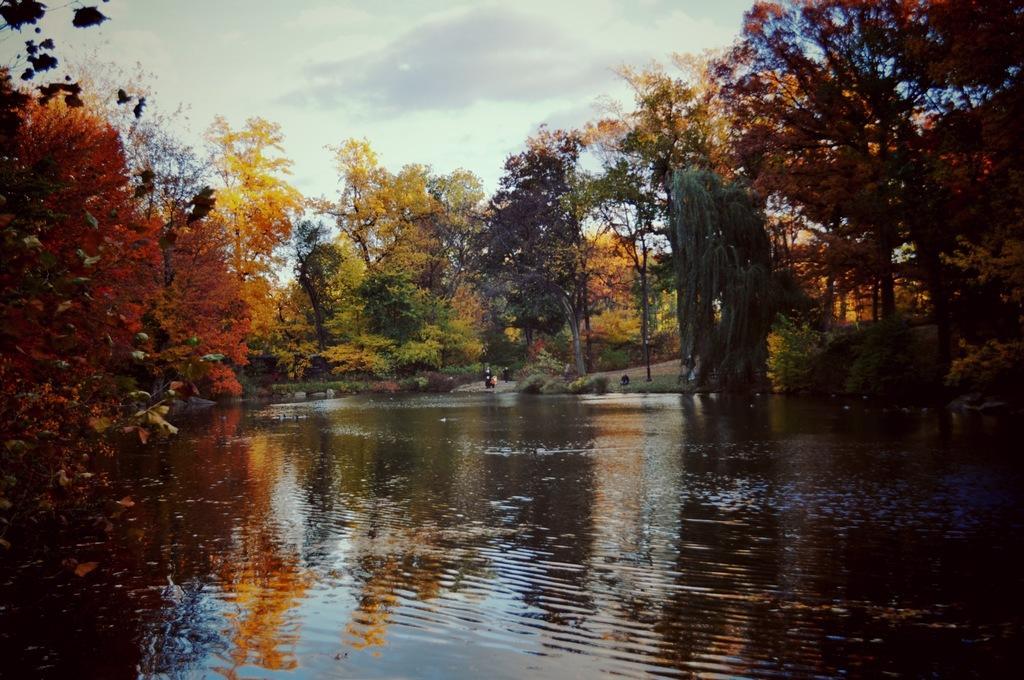Can you describe this image briefly? In this image there is water at the bottom. There are trees on either side of the water. At the top there is the sky. On the right side there are few people on the land. 